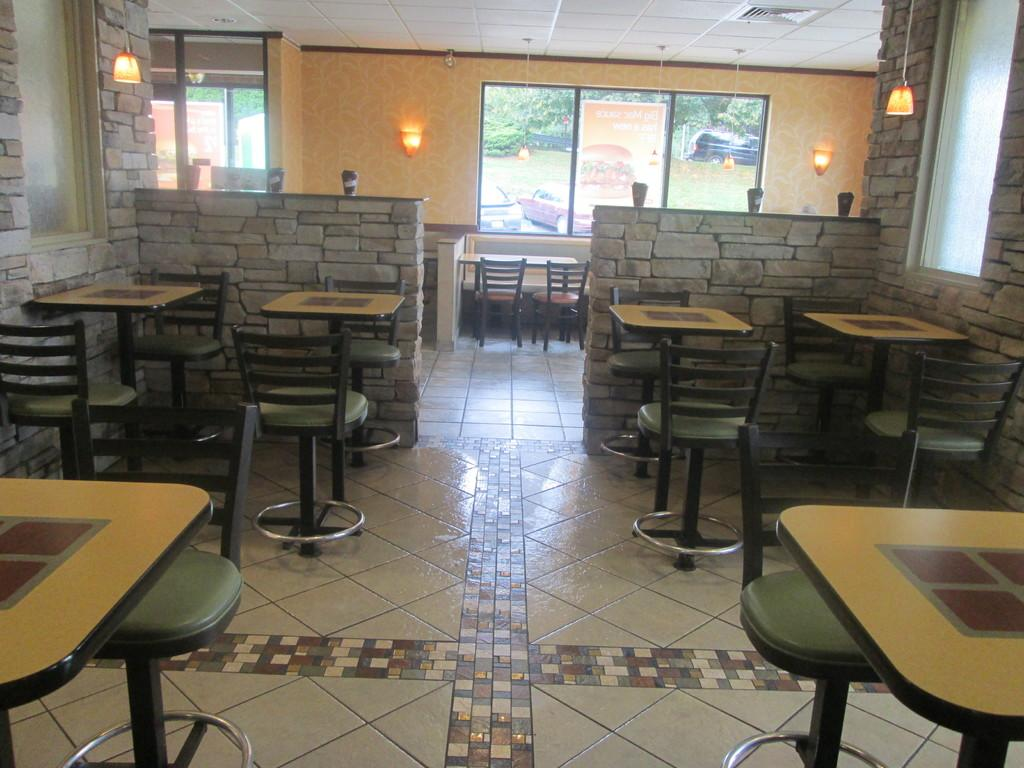What type of furniture is present in the image? There are tables and chairs in the image. What architectural features can be seen in the image? There are windows, lights, and a wall in the image. What is the setting of the image? The image is taken in a restaurant. What is the time of day when the image was taken? The image is taken during the day. What natural elements are present in the image? There are trees and grass in the middle of the image. How many dogs are sitting at the desk in the image? There are no dogs or desks present in the image. What type of ear is visible on the person in the image? There are no people or ears visible in the image. 